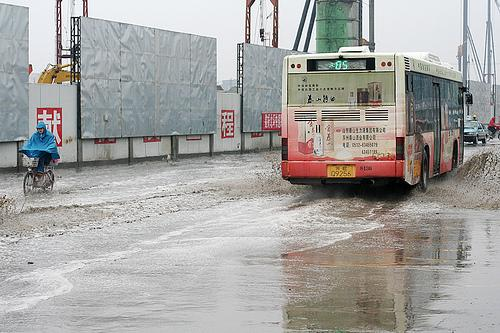Which object is in the greatest danger? bike 